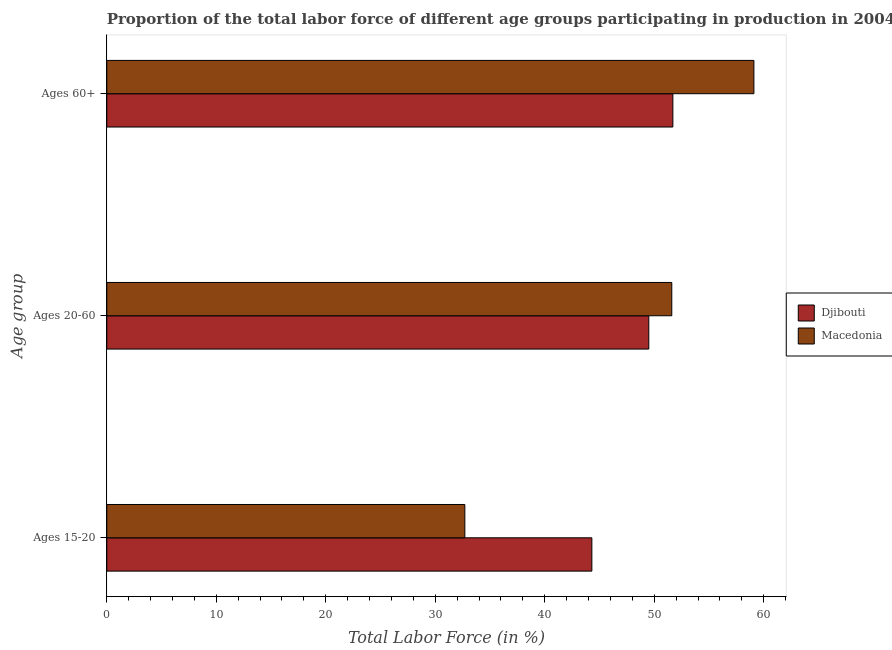How many groups of bars are there?
Offer a terse response. 3. Are the number of bars on each tick of the Y-axis equal?
Your response must be concise. Yes. How many bars are there on the 1st tick from the top?
Your answer should be compact. 2. What is the label of the 3rd group of bars from the top?
Keep it short and to the point. Ages 15-20. What is the percentage of labor force within the age group 20-60 in Macedonia?
Provide a succinct answer. 51.6. Across all countries, what is the maximum percentage of labor force within the age group 15-20?
Offer a terse response. 44.3. Across all countries, what is the minimum percentage of labor force within the age group 20-60?
Your answer should be very brief. 49.5. In which country was the percentage of labor force within the age group 15-20 maximum?
Your answer should be very brief. Djibouti. In which country was the percentage of labor force within the age group 20-60 minimum?
Offer a very short reply. Djibouti. What is the total percentage of labor force within the age group 20-60 in the graph?
Give a very brief answer. 101.1. What is the difference between the percentage of labor force above age 60 in Djibouti and that in Macedonia?
Ensure brevity in your answer.  -7.4. What is the difference between the percentage of labor force within the age group 20-60 in Djibouti and the percentage of labor force above age 60 in Macedonia?
Offer a very short reply. -9.6. What is the average percentage of labor force above age 60 per country?
Your answer should be compact. 55.4. What is the difference between the percentage of labor force within the age group 20-60 and percentage of labor force above age 60 in Djibouti?
Provide a succinct answer. -2.2. What is the ratio of the percentage of labor force within the age group 15-20 in Macedonia to that in Djibouti?
Your answer should be very brief. 0.74. What is the difference between the highest and the second highest percentage of labor force within the age group 20-60?
Make the answer very short. 2.1. What is the difference between the highest and the lowest percentage of labor force within the age group 20-60?
Provide a succinct answer. 2.1. In how many countries, is the percentage of labor force within the age group 15-20 greater than the average percentage of labor force within the age group 15-20 taken over all countries?
Your answer should be compact. 1. What does the 2nd bar from the top in Ages 60+ represents?
Your response must be concise. Djibouti. What does the 2nd bar from the bottom in Ages 15-20 represents?
Keep it short and to the point. Macedonia. Is it the case that in every country, the sum of the percentage of labor force within the age group 15-20 and percentage of labor force within the age group 20-60 is greater than the percentage of labor force above age 60?
Your answer should be compact. Yes. How many bars are there?
Provide a succinct answer. 6. Are all the bars in the graph horizontal?
Offer a very short reply. Yes. How many countries are there in the graph?
Provide a succinct answer. 2. What is the difference between two consecutive major ticks on the X-axis?
Your answer should be very brief. 10. Does the graph contain any zero values?
Make the answer very short. No. Does the graph contain grids?
Offer a terse response. No. How are the legend labels stacked?
Your response must be concise. Vertical. What is the title of the graph?
Ensure brevity in your answer.  Proportion of the total labor force of different age groups participating in production in 2004. What is the label or title of the X-axis?
Provide a succinct answer. Total Labor Force (in %). What is the label or title of the Y-axis?
Offer a very short reply. Age group. What is the Total Labor Force (in %) of Djibouti in Ages 15-20?
Your response must be concise. 44.3. What is the Total Labor Force (in %) of Macedonia in Ages 15-20?
Your answer should be very brief. 32.7. What is the Total Labor Force (in %) of Djibouti in Ages 20-60?
Make the answer very short. 49.5. What is the Total Labor Force (in %) in Macedonia in Ages 20-60?
Give a very brief answer. 51.6. What is the Total Labor Force (in %) in Djibouti in Ages 60+?
Offer a very short reply. 51.7. What is the Total Labor Force (in %) of Macedonia in Ages 60+?
Your answer should be very brief. 59.1. Across all Age group, what is the maximum Total Labor Force (in %) of Djibouti?
Your answer should be compact. 51.7. Across all Age group, what is the maximum Total Labor Force (in %) of Macedonia?
Provide a succinct answer. 59.1. Across all Age group, what is the minimum Total Labor Force (in %) of Djibouti?
Make the answer very short. 44.3. Across all Age group, what is the minimum Total Labor Force (in %) of Macedonia?
Provide a succinct answer. 32.7. What is the total Total Labor Force (in %) of Djibouti in the graph?
Offer a terse response. 145.5. What is the total Total Labor Force (in %) of Macedonia in the graph?
Your answer should be very brief. 143.4. What is the difference between the Total Labor Force (in %) in Macedonia in Ages 15-20 and that in Ages 20-60?
Your answer should be compact. -18.9. What is the difference between the Total Labor Force (in %) in Djibouti in Ages 15-20 and that in Ages 60+?
Your answer should be very brief. -7.4. What is the difference between the Total Labor Force (in %) of Macedonia in Ages 15-20 and that in Ages 60+?
Give a very brief answer. -26.4. What is the difference between the Total Labor Force (in %) in Macedonia in Ages 20-60 and that in Ages 60+?
Make the answer very short. -7.5. What is the difference between the Total Labor Force (in %) in Djibouti in Ages 15-20 and the Total Labor Force (in %) in Macedonia in Ages 60+?
Offer a very short reply. -14.8. What is the difference between the Total Labor Force (in %) of Djibouti in Ages 20-60 and the Total Labor Force (in %) of Macedonia in Ages 60+?
Your answer should be compact. -9.6. What is the average Total Labor Force (in %) of Djibouti per Age group?
Your answer should be compact. 48.5. What is the average Total Labor Force (in %) of Macedonia per Age group?
Offer a very short reply. 47.8. What is the difference between the Total Labor Force (in %) in Djibouti and Total Labor Force (in %) in Macedonia in Ages 15-20?
Provide a succinct answer. 11.6. What is the difference between the Total Labor Force (in %) in Djibouti and Total Labor Force (in %) in Macedonia in Ages 60+?
Offer a terse response. -7.4. What is the ratio of the Total Labor Force (in %) in Djibouti in Ages 15-20 to that in Ages 20-60?
Offer a terse response. 0.89. What is the ratio of the Total Labor Force (in %) in Macedonia in Ages 15-20 to that in Ages 20-60?
Provide a succinct answer. 0.63. What is the ratio of the Total Labor Force (in %) in Djibouti in Ages 15-20 to that in Ages 60+?
Your answer should be very brief. 0.86. What is the ratio of the Total Labor Force (in %) of Macedonia in Ages 15-20 to that in Ages 60+?
Provide a succinct answer. 0.55. What is the ratio of the Total Labor Force (in %) of Djibouti in Ages 20-60 to that in Ages 60+?
Give a very brief answer. 0.96. What is the ratio of the Total Labor Force (in %) in Macedonia in Ages 20-60 to that in Ages 60+?
Offer a terse response. 0.87. What is the difference between the highest and the lowest Total Labor Force (in %) of Macedonia?
Your answer should be very brief. 26.4. 